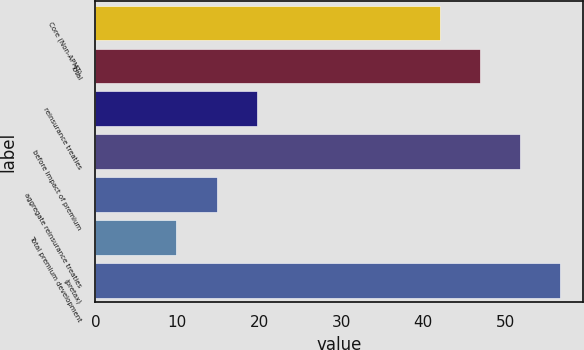<chart> <loc_0><loc_0><loc_500><loc_500><bar_chart><fcel>Core (Non-APMT)<fcel>Total<fcel>reinsurance treaties<fcel>before impact of premium<fcel>aggregate reinsurance treaties<fcel>Total premium development<fcel>(pretax)<nl><fcel>42<fcel>46.9<fcel>19.7<fcel>51.8<fcel>14.8<fcel>9.9<fcel>56.7<nl></chart> 